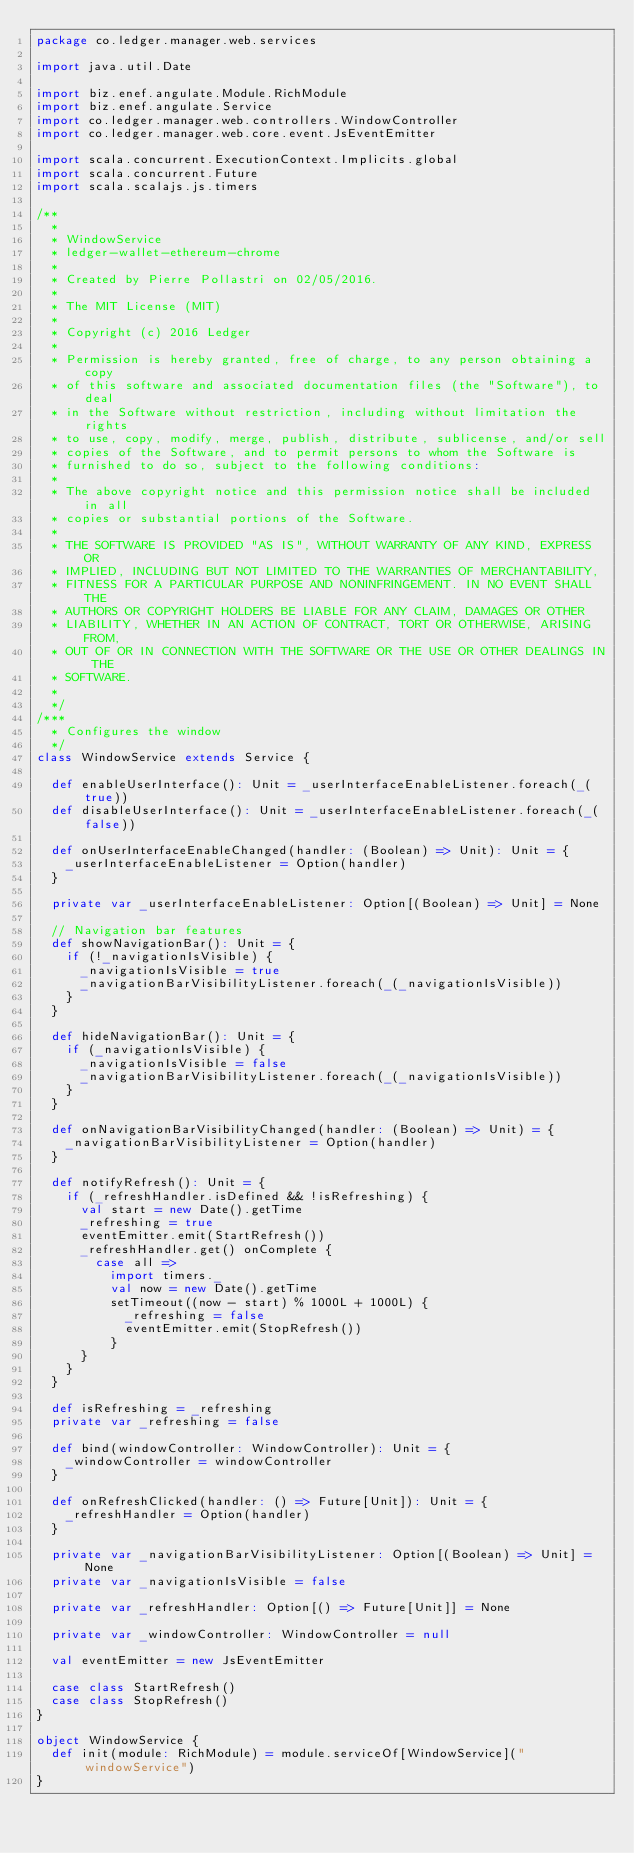<code> <loc_0><loc_0><loc_500><loc_500><_Scala_>package co.ledger.manager.web.services

import java.util.Date

import biz.enef.angulate.Module.RichModule
import biz.enef.angulate.Service
import co.ledger.manager.web.controllers.WindowController
import co.ledger.manager.web.core.event.JsEventEmitter

import scala.concurrent.ExecutionContext.Implicits.global
import scala.concurrent.Future
import scala.scalajs.js.timers

/**
  *
  * WindowService
  * ledger-wallet-ethereum-chrome
  *
  * Created by Pierre Pollastri on 02/05/2016.
  *
  * The MIT License (MIT)
  *
  * Copyright (c) 2016 Ledger
  *
  * Permission is hereby granted, free of charge, to any person obtaining a copy
  * of this software and associated documentation files (the "Software"), to deal
  * in the Software without restriction, including without limitation the rights
  * to use, copy, modify, merge, publish, distribute, sublicense, and/or sell
  * copies of the Software, and to permit persons to whom the Software is
  * furnished to do so, subject to the following conditions:
  *
  * The above copyright notice and this permission notice shall be included in all
  * copies or substantial portions of the Software.
  *
  * THE SOFTWARE IS PROVIDED "AS IS", WITHOUT WARRANTY OF ANY KIND, EXPRESS OR
  * IMPLIED, INCLUDING BUT NOT LIMITED TO THE WARRANTIES OF MERCHANTABILITY,
  * FITNESS FOR A PARTICULAR PURPOSE AND NONINFRINGEMENT. IN NO EVENT SHALL THE
  * AUTHORS OR COPYRIGHT HOLDERS BE LIABLE FOR ANY CLAIM, DAMAGES OR OTHER
  * LIABILITY, WHETHER IN AN ACTION OF CONTRACT, TORT OR OTHERWISE, ARISING FROM,
  * OUT OF OR IN CONNECTION WITH THE SOFTWARE OR THE USE OR OTHER DEALINGS IN THE
  * SOFTWARE.
  *
  */
/***
  * Configures the window
  */
class WindowService extends Service {

  def enableUserInterface(): Unit = _userInterfaceEnableListener.foreach(_(true))
  def disableUserInterface(): Unit = _userInterfaceEnableListener.foreach(_(false))

  def onUserInterfaceEnableChanged(handler: (Boolean) => Unit): Unit = {
    _userInterfaceEnableListener = Option(handler)
  }

  private var _userInterfaceEnableListener: Option[(Boolean) => Unit] = None

  // Navigation bar features
  def showNavigationBar(): Unit = {
    if (!_navigationIsVisible) {
      _navigationIsVisible = true
      _navigationBarVisibilityListener.foreach(_(_navigationIsVisible))
    }
  }

  def hideNavigationBar(): Unit = {
    if (_navigationIsVisible) {
      _navigationIsVisible = false
      _navigationBarVisibilityListener.foreach(_(_navigationIsVisible))
    }
  }

  def onNavigationBarVisibilityChanged(handler: (Boolean) => Unit) = {
    _navigationBarVisibilityListener = Option(handler)
  }

  def notifyRefresh(): Unit = {
    if (_refreshHandler.isDefined && !isRefreshing) {
      val start = new Date().getTime
      _refreshing = true
      eventEmitter.emit(StartRefresh())
      _refreshHandler.get() onComplete {
        case all =>
          import timers._
          val now = new Date().getTime
          setTimeout((now - start) % 1000L + 1000L) {
            _refreshing = false
            eventEmitter.emit(StopRefresh())
          }
      }
    }
  }

  def isRefreshing = _refreshing
  private var _refreshing = false

  def bind(windowController: WindowController): Unit = {
    _windowController = windowController
  }

  def onRefreshClicked(handler: () => Future[Unit]): Unit = {
    _refreshHandler = Option(handler)
  }

  private var _navigationBarVisibilityListener: Option[(Boolean) => Unit] = None
  private var _navigationIsVisible = false

  private var _refreshHandler: Option[() => Future[Unit]] = None

  private var _windowController: WindowController = null

  val eventEmitter = new JsEventEmitter

  case class StartRefresh()
  case class StopRefresh()
}

object WindowService {
  def init(module: RichModule) = module.serviceOf[WindowService]("windowService")
}</code> 